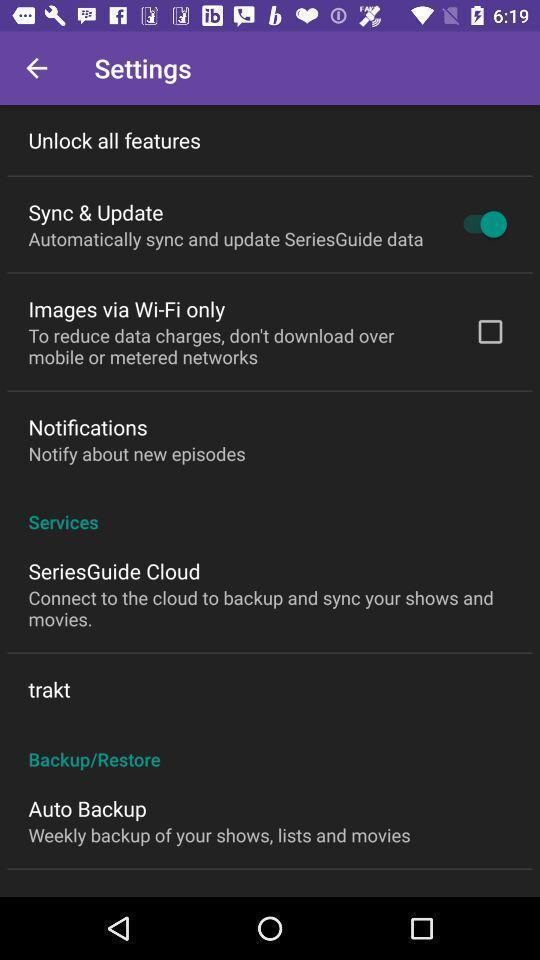Give me a narrative description of this picture. Settings page. 